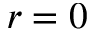Convert formula to latex. <formula><loc_0><loc_0><loc_500><loc_500>r = 0</formula> 